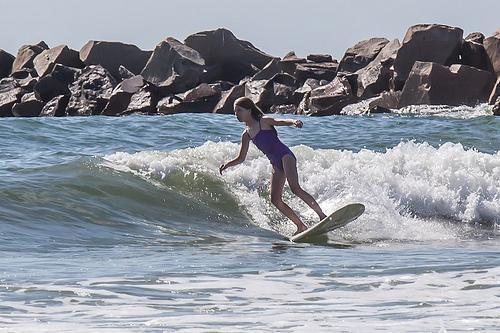How many waves are cresting?
Give a very brief answer. 1. 